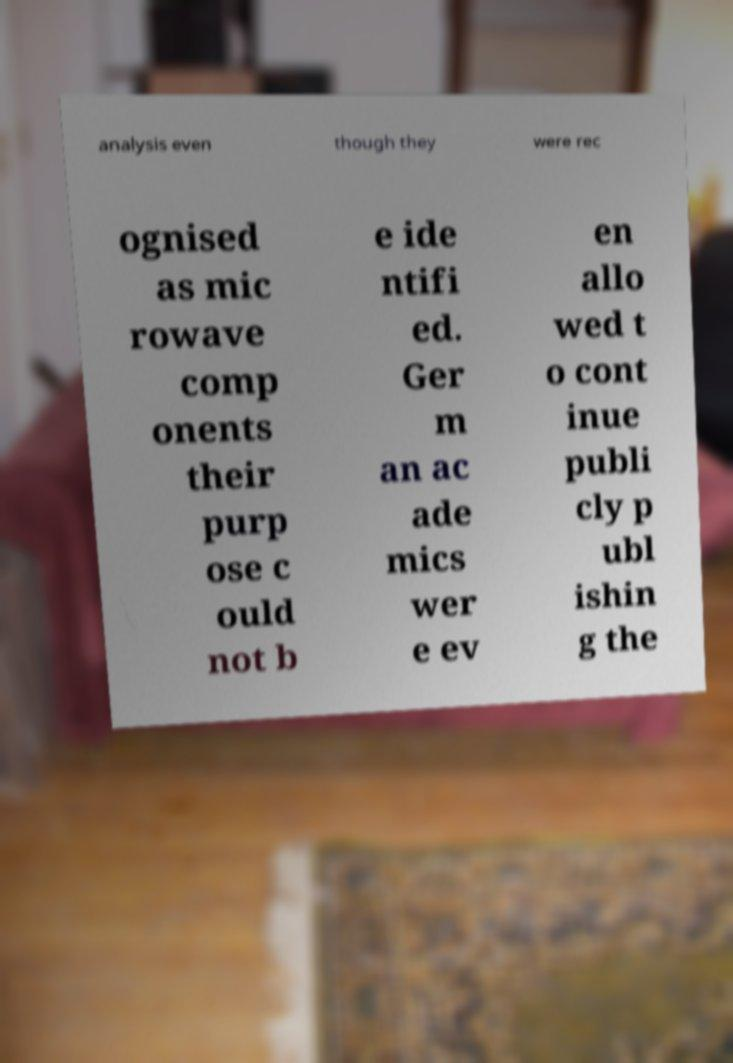Could you extract and type out the text from this image? analysis even though they were rec ognised as mic rowave comp onents their purp ose c ould not b e ide ntifi ed. Ger m an ac ade mics wer e ev en allo wed t o cont inue publi cly p ubl ishin g the 